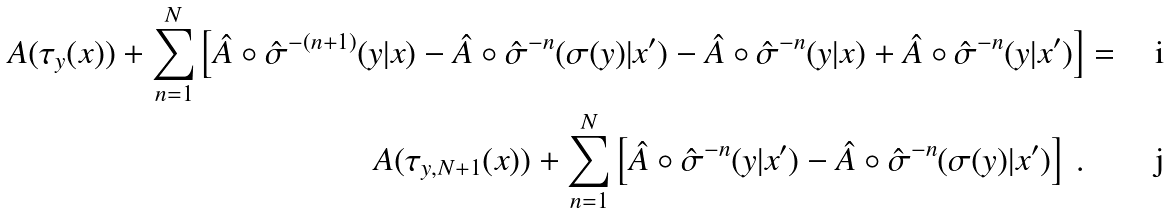Convert formula to latex. <formula><loc_0><loc_0><loc_500><loc_500>A ( \tau _ { y } ( x ) ) + \sum _ { n = 1 } ^ { N } \left [ \hat { A } \circ \hat { \sigma } ^ { - ( n + 1 ) } ( y | x ) - \hat { A } \circ \hat { \sigma } ^ { - n } ( \sigma ( y ) | x ^ { \prime } ) - \hat { A } \circ \hat { \sigma } ^ { - n } ( y | x ) + \hat { A } \circ \hat { \sigma } ^ { - n } ( y | x ^ { \prime } ) \right ] & = \\ A ( \tau _ { y , N + 1 } ( x ) ) + \sum _ { n = 1 } ^ { N } \left [ \hat { A } \circ \hat { \sigma } ^ { - n } ( y | x ^ { \prime } ) - \hat { A } \circ \hat { \sigma } ^ { - n } ( \sigma ( y ) | x ^ { \prime } ) \right ] \ .</formula> 